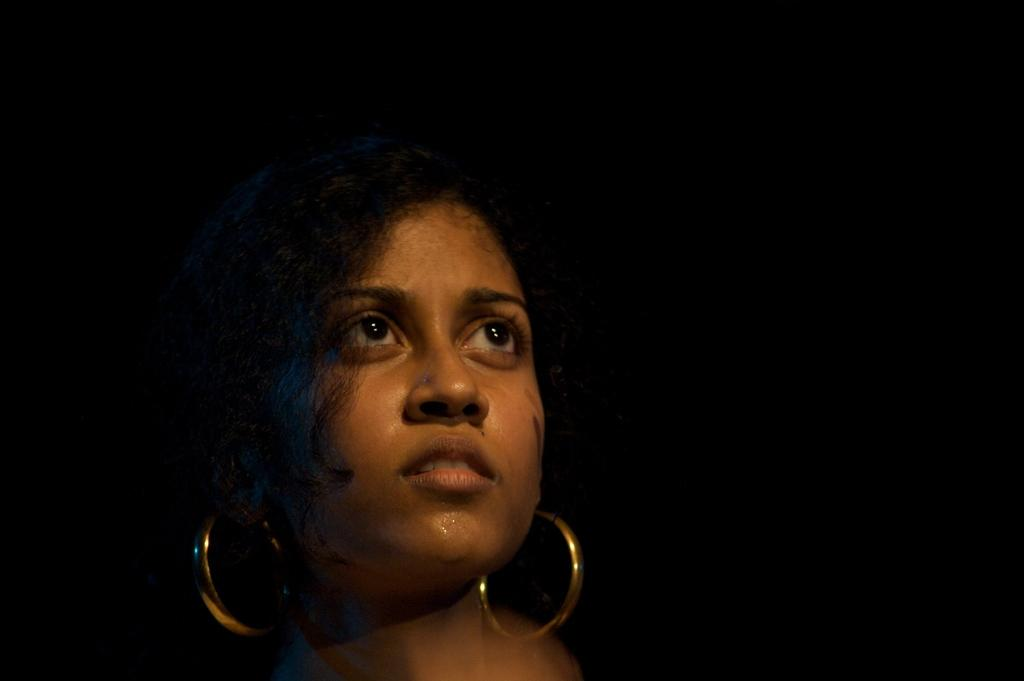Who is present in the image? There is a woman in the image. What is the woman doing in the image? The woman is looking to the right side. What is the color of the background in the image? The background of the image is black. What type of wine is the woman teaching about in the image? There is no wine or teaching activity present in the image; it only features a woman looking to the right side with a black background. 